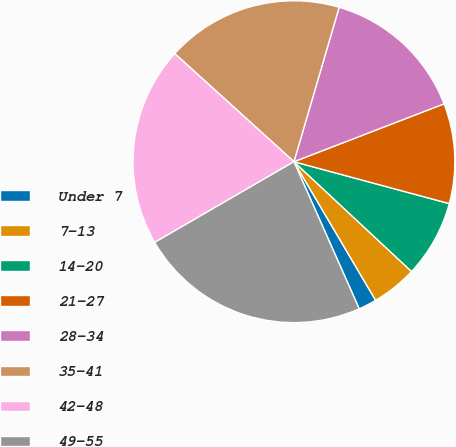Convert chart. <chart><loc_0><loc_0><loc_500><loc_500><pie_chart><fcel>Under 7<fcel>7-13<fcel>14-20<fcel>21-27<fcel>28-34<fcel>35-41<fcel>42-48<fcel>49-55<nl><fcel>1.83%<fcel>4.57%<fcel>7.76%<fcel>10.05%<fcel>14.61%<fcel>17.81%<fcel>20.09%<fcel>23.29%<nl></chart> 